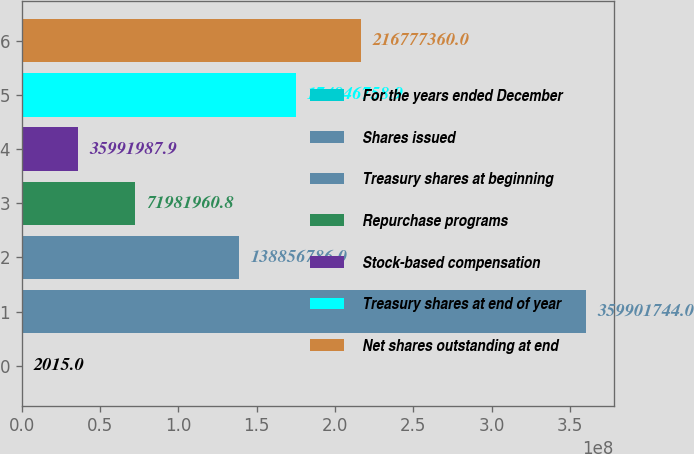Convert chart to OTSL. <chart><loc_0><loc_0><loc_500><loc_500><bar_chart><fcel>For the years ended December<fcel>Shares issued<fcel>Treasury shares at beginning<fcel>Repurchase programs<fcel>Stock-based compensation<fcel>Treasury shares at end of year<fcel>Net shares outstanding at end<nl><fcel>2015<fcel>3.59902e+08<fcel>1.38857e+08<fcel>7.1982e+07<fcel>3.5992e+07<fcel>1.74847e+08<fcel>2.16777e+08<nl></chart> 